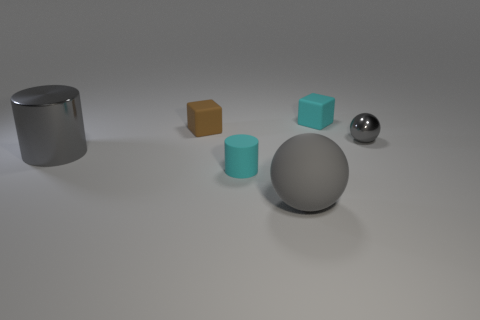There is a gray metallic thing that is on the right side of the gray cylinder; does it have the same size as the cylinder that is right of the large gray metallic object?
Your response must be concise. Yes. Is there another gray sphere of the same size as the gray matte ball?
Offer a very short reply. No. There is a cyan object that is in front of the tiny gray ball; how many balls are in front of it?
Your response must be concise. 1. What material is the large gray sphere?
Your response must be concise. Rubber. What number of cyan things are to the right of the cyan block?
Keep it short and to the point. 0. Do the matte ball and the shiny sphere have the same color?
Give a very brief answer. Yes. How many big rubber balls have the same color as the small shiny sphere?
Offer a very short reply. 1. Is the number of cyan metal cylinders greater than the number of cylinders?
Your answer should be very brief. No. There is a object that is both behind the gray metal cylinder and in front of the small brown thing; how big is it?
Keep it short and to the point. Small. Do the big object that is behind the gray rubber object and the small cyan thing in front of the small brown rubber cube have the same material?
Ensure brevity in your answer.  No. 